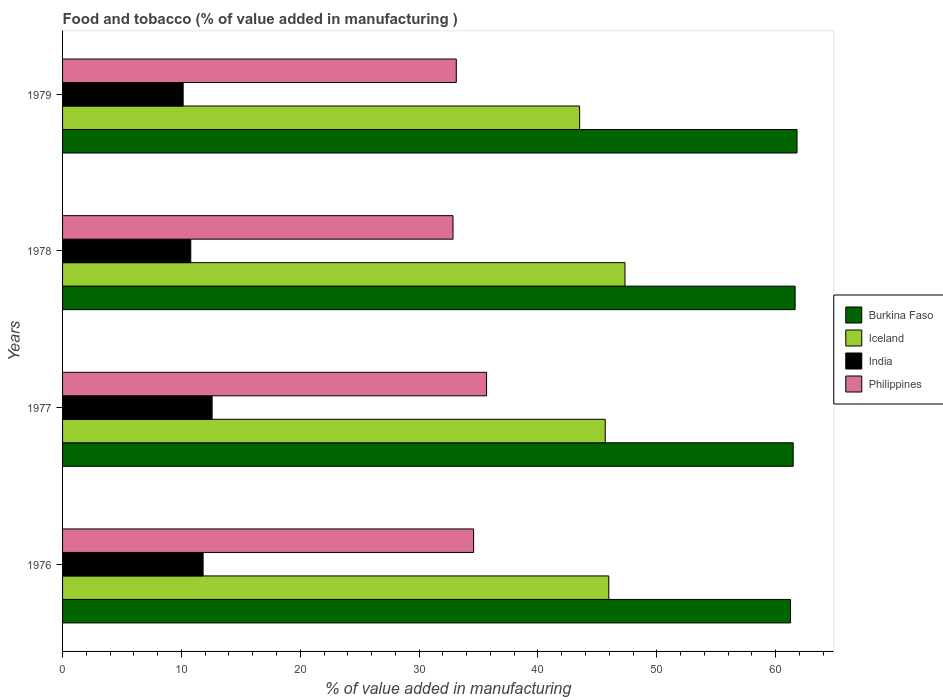How many different coloured bars are there?
Provide a short and direct response. 4. Are the number of bars on each tick of the Y-axis equal?
Your answer should be very brief. Yes. How many bars are there on the 4th tick from the bottom?
Offer a very short reply. 4. What is the value added in manufacturing food and tobacco in Philippines in 1978?
Your response must be concise. 32.85. Across all years, what is the maximum value added in manufacturing food and tobacco in Burkina Faso?
Provide a short and direct response. 61.8. Across all years, what is the minimum value added in manufacturing food and tobacco in Burkina Faso?
Provide a short and direct response. 61.26. In which year was the value added in manufacturing food and tobacco in Iceland maximum?
Ensure brevity in your answer.  1978. In which year was the value added in manufacturing food and tobacco in India minimum?
Ensure brevity in your answer.  1979. What is the total value added in manufacturing food and tobacco in Iceland in the graph?
Give a very brief answer. 182.46. What is the difference between the value added in manufacturing food and tobacco in Burkina Faso in 1977 and that in 1978?
Your answer should be very brief. -0.16. What is the difference between the value added in manufacturing food and tobacco in India in 1978 and the value added in manufacturing food and tobacco in Iceland in 1976?
Keep it short and to the point. -35.17. What is the average value added in manufacturing food and tobacco in India per year?
Provide a short and direct response. 11.34. In the year 1978, what is the difference between the value added in manufacturing food and tobacco in Iceland and value added in manufacturing food and tobacco in India?
Your response must be concise. 36.54. What is the ratio of the value added in manufacturing food and tobacco in Iceland in 1977 to that in 1979?
Your response must be concise. 1.05. Is the value added in manufacturing food and tobacco in Philippines in 1976 less than that in 1979?
Provide a succinct answer. No. What is the difference between the highest and the second highest value added in manufacturing food and tobacco in India?
Your answer should be very brief. 0.76. What is the difference between the highest and the lowest value added in manufacturing food and tobacco in Philippines?
Make the answer very short. 2.82. Is it the case that in every year, the sum of the value added in manufacturing food and tobacco in India and value added in manufacturing food and tobacco in Philippines is greater than the sum of value added in manufacturing food and tobacco in Iceland and value added in manufacturing food and tobacco in Burkina Faso?
Ensure brevity in your answer.  Yes. What does the 3rd bar from the top in 1979 represents?
Give a very brief answer. Iceland. What does the 2nd bar from the bottom in 1978 represents?
Your answer should be very brief. Iceland. Is it the case that in every year, the sum of the value added in manufacturing food and tobacco in Burkina Faso and value added in manufacturing food and tobacco in Iceland is greater than the value added in manufacturing food and tobacco in Philippines?
Your answer should be compact. Yes. How many bars are there?
Provide a short and direct response. 16. Are all the bars in the graph horizontal?
Your answer should be very brief. Yes. Are the values on the major ticks of X-axis written in scientific E-notation?
Your answer should be compact. No. Does the graph contain any zero values?
Offer a very short reply. No. Does the graph contain grids?
Your response must be concise. No. How are the legend labels stacked?
Ensure brevity in your answer.  Vertical. What is the title of the graph?
Offer a very short reply. Food and tobacco (% of value added in manufacturing ). Does "Andorra" appear as one of the legend labels in the graph?
Your answer should be compact. No. What is the label or title of the X-axis?
Ensure brevity in your answer.  % of value added in manufacturing. What is the label or title of the Y-axis?
Your response must be concise. Years. What is the % of value added in manufacturing in Burkina Faso in 1976?
Your answer should be very brief. 61.26. What is the % of value added in manufacturing of Iceland in 1976?
Provide a succinct answer. 45.96. What is the % of value added in manufacturing in India in 1976?
Give a very brief answer. 11.83. What is the % of value added in manufacturing of Philippines in 1976?
Provide a succinct answer. 34.59. What is the % of value added in manufacturing in Burkina Faso in 1977?
Your answer should be very brief. 61.48. What is the % of value added in manufacturing of Iceland in 1977?
Offer a terse response. 45.66. What is the % of value added in manufacturing in India in 1977?
Offer a terse response. 12.58. What is the % of value added in manufacturing of Philippines in 1977?
Your answer should be very brief. 35.68. What is the % of value added in manufacturing in Burkina Faso in 1978?
Make the answer very short. 61.64. What is the % of value added in manufacturing in Iceland in 1978?
Provide a succinct answer. 47.33. What is the % of value added in manufacturing of India in 1978?
Keep it short and to the point. 10.79. What is the % of value added in manufacturing of Philippines in 1978?
Provide a succinct answer. 32.85. What is the % of value added in manufacturing of Burkina Faso in 1979?
Your answer should be very brief. 61.8. What is the % of value added in manufacturing in Iceland in 1979?
Keep it short and to the point. 43.51. What is the % of value added in manufacturing of India in 1979?
Provide a short and direct response. 10.15. What is the % of value added in manufacturing in Philippines in 1979?
Give a very brief answer. 33.13. Across all years, what is the maximum % of value added in manufacturing in Burkina Faso?
Offer a terse response. 61.8. Across all years, what is the maximum % of value added in manufacturing of Iceland?
Offer a terse response. 47.33. Across all years, what is the maximum % of value added in manufacturing of India?
Ensure brevity in your answer.  12.58. Across all years, what is the maximum % of value added in manufacturing in Philippines?
Provide a short and direct response. 35.68. Across all years, what is the minimum % of value added in manufacturing in Burkina Faso?
Your answer should be very brief. 61.26. Across all years, what is the minimum % of value added in manufacturing of Iceland?
Your answer should be very brief. 43.51. Across all years, what is the minimum % of value added in manufacturing in India?
Your answer should be compact. 10.15. Across all years, what is the minimum % of value added in manufacturing in Philippines?
Your answer should be compact. 32.85. What is the total % of value added in manufacturing of Burkina Faso in the graph?
Your response must be concise. 246.19. What is the total % of value added in manufacturing of Iceland in the graph?
Provide a succinct answer. 182.46. What is the total % of value added in manufacturing of India in the graph?
Make the answer very short. 45.35. What is the total % of value added in manufacturing of Philippines in the graph?
Make the answer very short. 136.25. What is the difference between the % of value added in manufacturing of Burkina Faso in 1976 and that in 1977?
Keep it short and to the point. -0.23. What is the difference between the % of value added in manufacturing in Iceland in 1976 and that in 1977?
Give a very brief answer. 0.3. What is the difference between the % of value added in manufacturing in India in 1976 and that in 1977?
Your answer should be very brief. -0.76. What is the difference between the % of value added in manufacturing of Philippines in 1976 and that in 1977?
Offer a very short reply. -1.09. What is the difference between the % of value added in manufacturing in Burkina Faso in 1976 and that in 1978?
Offer a terse response. -0.39. What is the difference between the % of value added in manufacturing in Iceland in 1976 and that in 1978?
Keep it short and to the point. -1.36. What is the difference between the % of value added in manufacturing of India in 1976 and that in 1978?
Offer a terse response. 1.04. What is the difference between the % of value added in manufacturing of Philippines in 1976 and that in 1978?
Provide a succinct answer. 1.73. What is the difference between the % of value added in manufacturing in Burkina Faso in 1976 and that in 1979?
Make the answer very short. -0.55. What is the difference between the % of value added in manufacturing of Iceland in 1976 and that in 1979?
Make the answer very short. 2.46. What is the difference between the % of value added in manufacturing in India in 1976 and that in 1979?
Make the answer very short. 1.68. What is the difference between the % of value added in manufacturing of Philippines in 1976 and that in 1979?
Provide a succinct answer. 1.46. What is the difference between the % of value added in manufacturing in Burkina Faso in 1977 and that in 1978?
Offer a very short reply. -0.16. What is the difference between the % of value added in manufacturing of Iceland in 1977 and that in 1978?
Provide a succinct answer. -1.66. What is the difference between the % of value added in manufacturing in India in 1977 and that in 1978?
Keep it short and to the point. 1.8. What is the difference between the % of value added in manufacturing in Philippines in 1977 and that in 1978?
Provide a short and direct response. 2.82. What is the difference between the % of value added in manufacturing of Burkina Faso in 1977 and that in 1979?
Offer a terse response. -0.32. What is the difference between the % of value added in manufacturing in Iceland in 1977 and that in 1979?
Provide a succinct answer. 2.16. What is the difference between the % of value added in manufacturing in India in 1977 and that in 1979?
Keep it short and to the point. 2.44. What is the difference between the % of value added in manufacturing in Philippines in 1977 and that in 1979?
Keep it short and to the point. 2.55. What is the difference between the % of value added in manufacturing of Burkina Faso in 1978 and that in 1979?
Provide a succinct answer. -0.16. What is the difference between the % of value added in manufacturing in Iceland in 1978 and that in 1979?
Your answer should be very brief. 3.82. What is the difference between the % of value added in manufacturing of India in 1978 and that in 1979?
Offer a very short reply. 0.64. What is the difference between the % of value added in manufacturing of Philippines in 1978 and that in 1979?
Keep it short and to the point. -0.28. What is the difference between the % of value added in manufacturing in Burkina Faso in 1976 and the % of value added in manufacturing in Iceland in 1977?
Provide a succinct answer. 15.59. What is the difference between the % of value added in manufacturing of Burkina Faso in 1976 and the % of value added in manufacturing of India in 1977?
Provide a succinct answer. 48.67. What is the difference between the % of value added in manufacturing in Burkina Faso in 1976 and the % of value added in manufacturing in Philippines in 1977?
Offer a terse response. 25.58. What is the difference between the % of value added in manufacturing in Iceland in 1976 and the % of value added in manufacturing in India in 1977?
Your response must be concise. 33.38. What is the difference between the % of value added in manufacturing of Iceland in 1976 and the % of value added in manufacturing of Philippines in 1977?
Ensure brevity in your answer.  10.28. What is the difference between the % of value added in manufacturing in India in 1976 and the % of value added in manufacturing in Philippines in 1977?
Offer a very short reply. -23.85. What is the difference between the % of value added in manufacturing of Burkina Faso in 1976 and the % of value added in manufacturing of Iceland in 1978?
Keep it short and to the point. 13.93. What is the difference between the % of value added in manufacturing of Burkina Faso in 1976 and the % of value added in manufacturing of India in 1978?
Ensure brevity in your answer.  50.47. What is the difference between the % of value added in manufacturing of Burkina Faso in 1976 and the % of value added in manufacturing of Philippines in 1978?
Give a very brief answer. 28.4. What is the difference between the % of value added in manufacturing in Iceland in 1976 and the % of value added in manufacturing in India in 1978?
Keep it short and to the point. 35.17. What is the difference between the % of value added in manufacturing in Iceland in 1976 and the % of value added in manufacturing in Philippines in 1978?
Ensure brevity in your answer.  13.11. What is the difference between the % of value added in manufacturing of India in 1976 and the % of value added in manufacturing of Philippines in 1978?
Your answer should be compact. -21.03. What is the difference between the % of value added in manufacturing in Burkina Faso in 1976 and the % of value added in manufacturing in Iceland in 1979?
Your response must be concise. 17.75. What is the difference between the % of value added in manufacturing in Burkina Faso in 1976 and the % of value added in manufacturing in India in 1979?
Your answer should be compact. 51.11. What is the difference between the % of value added in manufacturing in Burkina Faso in 1976 and the % of value added in manufacturing in Philippines in 1979?
Give a very brief answer. 28.13. What is the difference between the % of value added in manufacturing in Iceland in 1976 and the % of value added in manufacturing in India in 1979?
Provide a short and direct response. 35.82. What is the difference between the % of value added in manufacturing in Iceland in 1976 and the % of value added in manufacturing in Philippines in 1979?
Provide a short and direct response. 12.83. What is the difference between the % of value added in manufacturing in India in 1976 and the % of value added in manufacturing in Philippines in 1979?
Keep it short and to the point. -21.3. What is the difference between the % of value added in manufacturing of Burkina Faso in 1977 and the % of value added in manufacturing of Iceland in 1978?
Keep it short and to the point. 14.16. What is the difference between the % of value added in manufacturing of Burkina Faso in 1977 and the % of value added in manufacturing of India in 1978?
Give a very brief answer. 50.69. What is the difference between the % of value added in manufacturing in Burkina Faso in 1977 and the % of value added in manufacturing in Philippines in 1978?
Provide a short and direct response. 28.63. What is the difference between the % of value added in manufacturing in Iceland in 1977 and the % of value added in manufacturing in India in 1978?
Your answer should be very brief. 34.87. What is the difference between the % of value added in manufacturing of Iceland in 1977 and the % of value added in manufacturing of Philippines in 1978?
Your response must be concise. 12.81. What is the difference between the % of value added in manufacturing of India in 1977 and the % of value added in manufacturing of Philippines in 1978?
Your response must be concise. -20.27. What is the difference between the % of value added in manufacturing of Burkina Faso in 1977 and the % of value added in manufacturing of Iceland in 1979?
Ensure brevity in your answer.  17.98. What is the difference between the % of value added in manufacturing of Burkina Faso in 1977 and the % of value added in manufacturing of India in 1979?
Offer a very short reply. 51.34. What is the difference between the % of value added in manufacturing in Burkina Faso in 1977 and the % of value added in manufacturing in Philippines in 1979?
Make the answer very short. 28.35. What is the difference between the % of value added in manufacturing of Iceland in 1977 and the % of value added in manufacturing of India in 1979?
Give a very brief answer. 35.52. What is the difference between the % of value added in manufacturing in Iceland in 1977 and the % of value added in manufacturing in Philippines in 1979?
Keep it short and to the point. 12.53. What is the difference between the % of value added in manufacturing of India in 1977 and the % of value added in manufacturing of Philippines in 1979?
Offer a terse response. -20.55. What is the difference between the % of value added in manufacturing of Burkina Faso in 1978 and the % of value added in manufacturing of Iceland in 1979?
Make the answer very short. 18.14. What is the difference between the % of value added in manufacturing in Burkina Faso in 1978 and the % of value added in manufacturing in India in 1979?
Ensure brevity in your answer.  51.5. What is the difference between the % of value added in manufacturing of Burkina Faso in 1978 and the % of value added in manufacturing of Philippines in 1979?
Provide a short and direct response. 28.51. What is the difference between the % of value added in manufacturing in Iceland in 1978 and the % of value added in manufacturing in India in 1979?
Your answer should be very brief. 37.18. What is the difference between the % of value added in manufacturing of Iceland in 1978 and the % of value added in manufacturing of Philippines in 1979?
Give a very brief answer. 14.2. What is the difference between the % of value added in manufacturing of India in 1978 and the % of value added in manufacturing of Philippines in 1979?
Provide a succinct answer. -22.34. What is the average % of value added in manufacturing of Burkina Faso per year?
Your answer should be compact. 61.55. What is the average % of value added in manufacturing of Iceland per year?
Offer a terse response. 45.62. What is the average % of value added in manufacturing in India per year?
Offer a terse response. 11.34. What is the average % of value added in manufacturing of Philippines per year?
Provide a succinct answer. 34.06. In the year 1976, what is the difference between the % of value added in manufacturing in Burkina Faso and % of value added in manufacturing in Iceland?
Give a very brief answer. 15.29. In the year 1976, what is the difference between the % of value added in manufacturing of Burkina Faso and % of value added in manufacturing of India?
Give a very brief answer. 49.43. In the year 1976, what is the difference between the % of value added in manufacturing in Burkina Faso and % of value added in manufacturing in Philippines?
Provide a succinct answer. 26.67. In the year 1976, what is the difference between the % of value added in manufacturing in Iceland and % of value added in manufacturing in India?
Provide a short and direct response. 34.14. In the year 1976, what is the difference between the % of value added in manufacturing of Iceland and % of value added in manufacturing of Philippines?
Your response must be concise. 11.37. In the year 1976, what is the difference between the % of value added in manufacturing in India and % of value added in manufacturing in Philippines?
Keep it short and to the point. -22.76. In the year 1977, what is the difference between the % of value added in manufacturing in Burkina Faso and % of value added in manufacturing in Iceland?
Give a very brief answer. 15.82. In the year 1977, what is the difference between the % of value added in manufacturing in Burkina Faso and % of value added in manufacturing in India?
Provide a succinct answer. 48.9. In the year 1977, what is the difference between the % of value added in manufacturing of Burkina Faso and % of value added in manufacturing of Philippines?
Your answer should be very brief. 25.8. In the year 1977, what is the difference between the % of value added in manufacturing in Iceland and % of value added in manufacturing in India?
Offer a terse response. 33.08. In the year 1977, what is the difference between the % of value added in manufacturing of Iceland and % of value added in manufacturing of Philippines?
Offer a terse response. 9.99. In the year 1977, what is the difference between the % of value added in manufacturing of India and % of value added in manufacturing of Philippines?
Give a very brief answer. -23.09. In the year 1978, what is the difference between the % of value added in manufacturing in Burkina Faso and % of value added in manufacturing in Iceland?
Your answer should be very brief. 14.32. In the year 1978, what is the difference between the % of value added in manufacturing of Burkina Faso and % of value added in manufacturing of India?
Make the answer very short. 50.85. In the year 1978, what is the difference between the % of value added in manufacturing in Burkina Faso and % of value added in manufacturing in Philippines?
Your response must be concise. 28.79. In the year 1978, what is the difference between the % of value added in manufacturing of Iceland and % of value added in manufacturing of India?
Provide a short and direct response. 36.54. In the year 1978, what is the difference between the % of value added in manufacturing of Iceland and % of value added in manufacturing of Philippines?
Keep it short and to the point. 14.47. In the year 1978, what is the difference between the % of value added in manufacturing of India and % of value added in manufacturing of Philippines?
Offer a terse response. -22.07. In the year 1979, what is the difference between the % of value added in manufacturing in Burkina Faso and % of value added in manufacturing in Iceland?
Make the answer very short. 18.3. In the year 1979, what is the difference between the % of value added in manufacturing in Burkina Faso and % of value added in manufacturing in India?
Ensure brevity in your answer.  51.66. In the year 1979, what is the difference between the % of value added in manufacturing in Burkina Faso and % of value added in manufacturing in Philippines?
Offer a very short reply. 28.67. In the year 1979, what is the difference between the % of value added in manufacturing in Iceland and % of value added in manufacturing in India?
Keep it short and to the point. 33.36. In the year 1979, what is the difference between the % of value added in manufacturing of Iceland and % of value added in manufacturing of Philippines?
Offer a terse response. 10.38. In the year 1979, what is the difference between the % of value added in manufacturing in India and % of value added in manufacturing in Philippines?
Your answer should be compact. -22.98. What is the ratio of the % of value added in manufacturing of India in 1976 to that in 1977?
Provide a short and direct response. 0.94. What is the ratio of the % of value added in manufacturing in Philippines in 1976 to that in 1977?
Your response must be concise. 0.97. What is the ratio of the % of value added in manufacturing in Iceland in 1976 to that in 1978?
Your answer should be very brief. 0.97. What is the ratio of the % of value added in manufacturing in India in 1976 to that in 1978?
Make the answer very short. 1.1. What is the ratio of the % of value added in manufacturing of Philippines in 1976 to that in 1978?
Your answer should be very brief. 1.05. What is the ratio of the % of value added in manufacturing of Iceland in 1976 to that in 1979?
Give a very brief answer. 1.06. What is the ratio of the % of value added in manufacturing of India in 1976 to that in 1979?
Offer a terse response. 1.17. What is the ratio of the % of value added in manufacturing of Philippines in 1976 to that in 1979?
Make the answer very short. 1.04. What is the ratio of the % of value added in manufacturing in Iceland in 1977 to that in 1978?
Make the answer very short. 0.96. What is the ratio of the % of value added in manufacturing of India in 1977 to that in 1978?
Provide a succinct answer. 1.17. What is the ratio of the % of value added in manufacturing in Philippines in 1977 to that in 1978?
Offer a terse response. 1.09. What is the ratio of the % of value added in manufacturing of Iceland in 1977 to that in 1979?
Ensure brevity in your answer.  1.05. What is the ratio of the % of value added in manufacturing in India in 1977 to that in 1979?
Ensure brevity in your answer.  1.24. What is the ratio of the % of value added in manufacturing of Iceland in 1978 to that in 1979?
Your answer should be very brief. 1.09. What is the ratio of the % of value added in manufacturing of India in 1978 to that in 1979?
Keep it short and to the point. 1.06. What is the ratio of the % of value added in manufacturing of Philippines in 1978 to that in 1979?
Give a very brief answer. 0.99. What is the difference between the highest and the second highest % of value added in manufacturing in Burkina Faso?
Give a very brief answer. 0.16. What is the difference between the highest and the second highest % of value added in manufacturing of Iceland?
Ensure brevity in your answer.  1.36. What is the difference between the highest and the second highest % of value added in manufacturing in India?
Your answer should be compact. 0.76. What is the difference between the highest and the second highest % of value added in manufacturing of Philippines?
Offer a terse response. 1.09. What is the difference between the highest and the lowest % of value added in manufacturing of Burkina Faso?
Provide a short and direct response. 0.55. What is the difference between the highest and the lowest % of value added in manufacturing in Iceland?
Your answer should be very brief. 3.82. What is the difference between the highest and the lowest % of value added in manufacturing in India?
Give a very brief answer. 2.44. What is the difference between the highest and the lowest % of value added in manufacturing in Philippines?
Offer a very short reply. 2.82. 